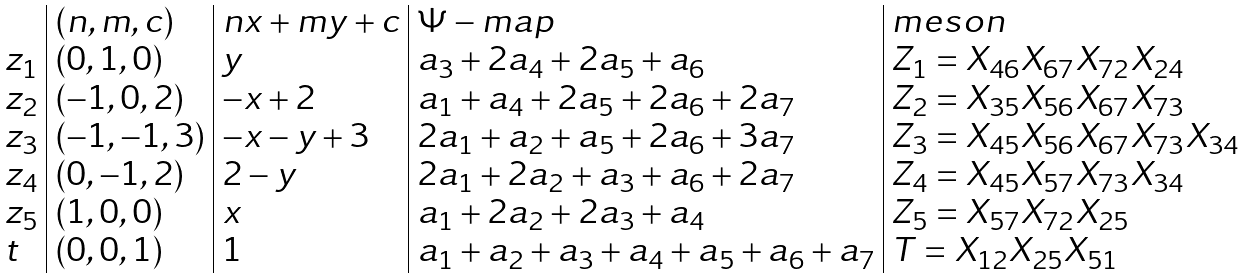Convert formula to latex. <formula><loc_0><loc_0><loc_500><loc_500>\begin{array} { l | l | l | l | l } & ( n , m , c ) & n x + m y + c & \Psi - m a p & m e s o n \\ z _ { 1 } & ( 0 , 1 , 0 ) & y & a _ { 3 } + 2 a _ { 4 } + 2 a _ { 5 } + a _ { 6 } & Z _ { 1 } = X _ { 4 6 } X _ { 6 7 } X _ { 7 2 } X _ { 2 4 } \\ z _ { 2 } & ( - 1 , 0 , 2 ) & - x + 2 & a _ { 1 } + a _ { 4 } + 2 a _ { 5 } + 2 a _ { 6 } + 2 a _ { 7 } & Z _ { 2 } = X _ { 3 5 } X _ { 5 6 } X _ { 6 7 } X _ { 7 3 } \\ z _ { 3 } & ( - 1 , - 1 , 3 ) & - x - y + 3 & 2 a _ { 1 } + a _ { 2 } + a _ { 5 } + 2 a _ { 6 } + 3 a _ { 7 } & Z _ { 3 } = X _ { 4 5 } X _ { 5 6 } X _ { 6 7 } X _ { 7 3 } X _ { 3 4 } \\ z _ { 4 } & ( 0 , - 1 , 2 ) & 2 - y & 2 a _ { 1 } + 2 a _ { 2 } + a _ { 3 } + a _ { 6 } + 2 a _ { 7 } & Z _ { 4 } = X _ { 4 5 } X _ { 5 7 } X _ { 7 3 } X _ { 3 4 } \\ z _ { 5 } & ( 1 , 0 , 0 ) & x & a _ { 1 } + 2 a _ { 2 } + 2 a _ { 3 } + a _ { 4 } & Z _ { 5 } = X _ { 5 7 } X _ { 7 2 } X _ { 2 5 } \\ t & ( 0 , 0 , 1 ) & 1 & a _ { 1 } + a _ { 2 } + a _ { 3 } + a _ { 4 } + a _ { 5 } + a _ { 6 } + a _ { 7 } & T = X _ { 1 2 } X _ { 2 5 } X _ { 5 1 } \end{array}</formula> 